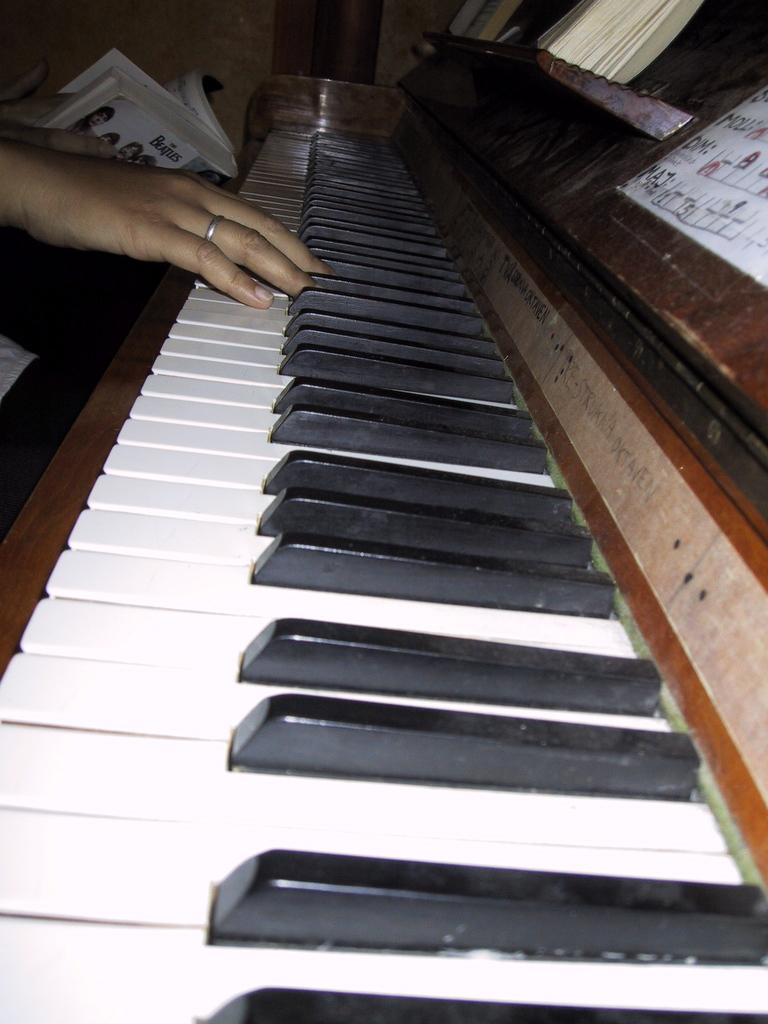What is the main object in the image? There is a piano in the image. What is the person doing with the piano? The person is typing on the piano. What else is the person holding in the image? The person is holding a book. What type of laborer can be seen working in the territory shown in the image? There is no laborer or territory present in the image; it features a person typing on a piano and holding a book. 